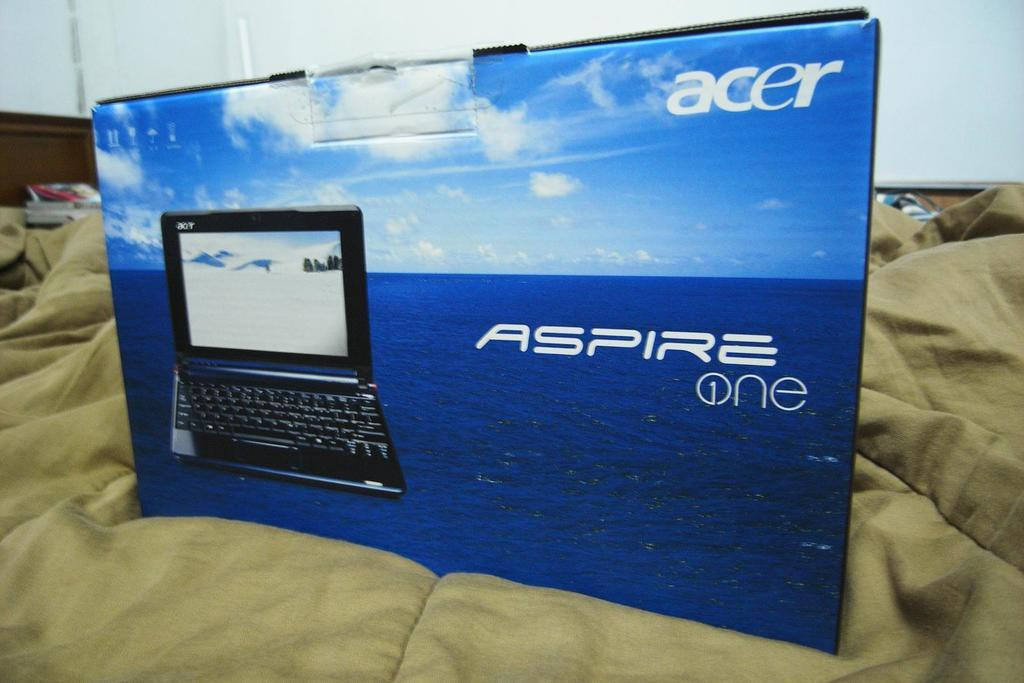<image>
Give a short and clear explanation of the subsequent image. A box displaying an Acer Aspire one laptop with a blue ocean behind it. 